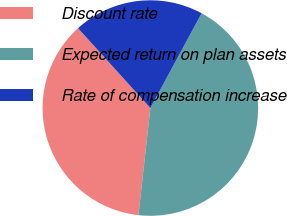Convert chart. <chart><loc_0><loc_0><loc_500><loc_500><pie_chart><fcel>Discount rate<fcel>Expected return on plan assets<fcel>Rate of compensation increase<nl><fcel>36.52%<fcel>43.87%<fcel>19.61%<nl></chart> 